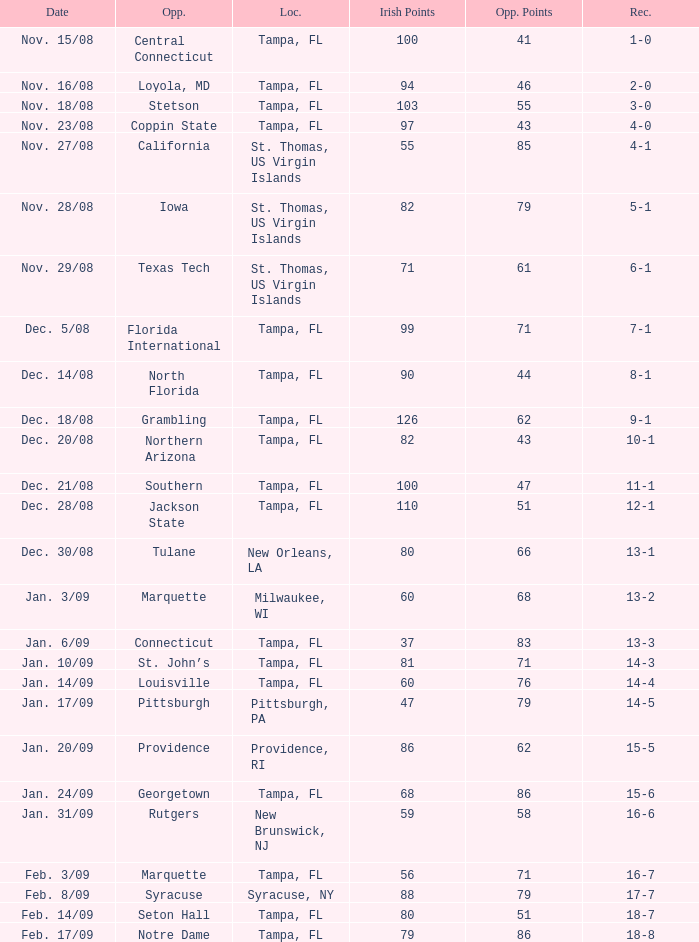What is the record where the opponent is central connecticut? 1-0. 